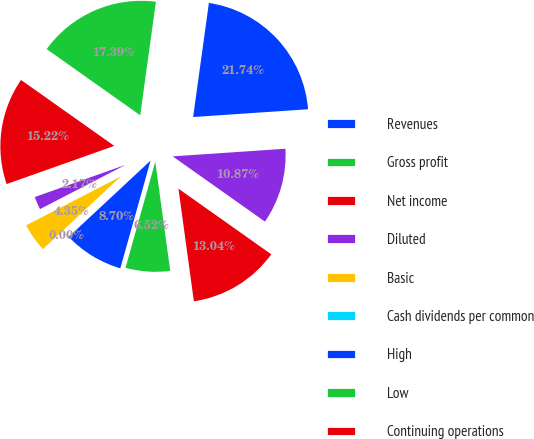Convert chart to OTSL. <chart><loc_0><loc_0><loc_500><loc_500><pie_chart><fcel>Revenues<fcel>Gross profit<fcel>Net income<fcel>Diluted<fcel>Basic<fcel>Cash dividends per common<fcel>High<fcel>Low<fcel>Continuing operations<fcel>Total<nl><fcel>21.74%<fcel>17.39%<fcel>15.22%<fcel>2.17%<fcel>4.35%<fcel>0.0%<fcel>8.7%<fcel>6.52%<fcel>13.04%<fcel>10.87%<nl></chart> 